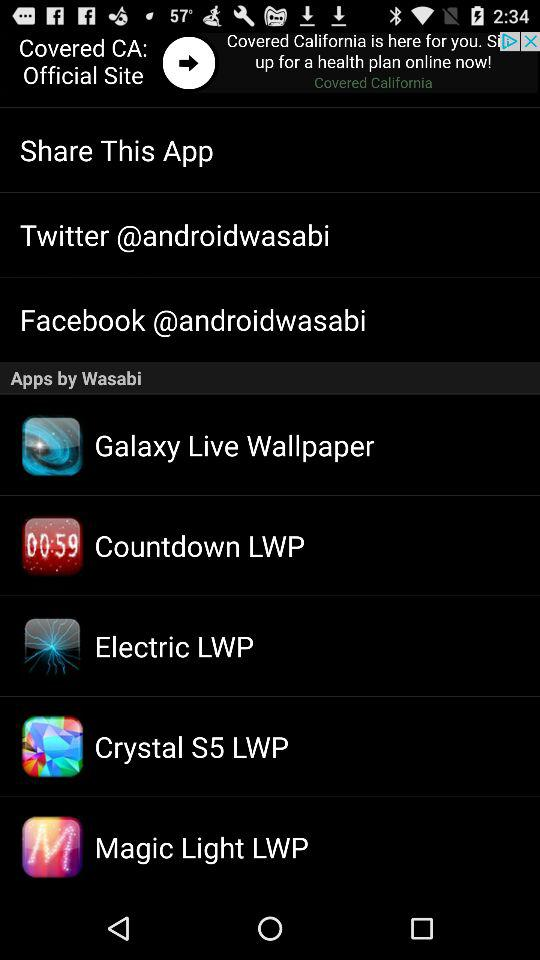How many social media links are on the page?
Answer the question using a single word or phrase. 2 